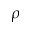Convert formula to latex. <formula><loc_0><loc_0><loc_500><loc_500>\rho</formula> 